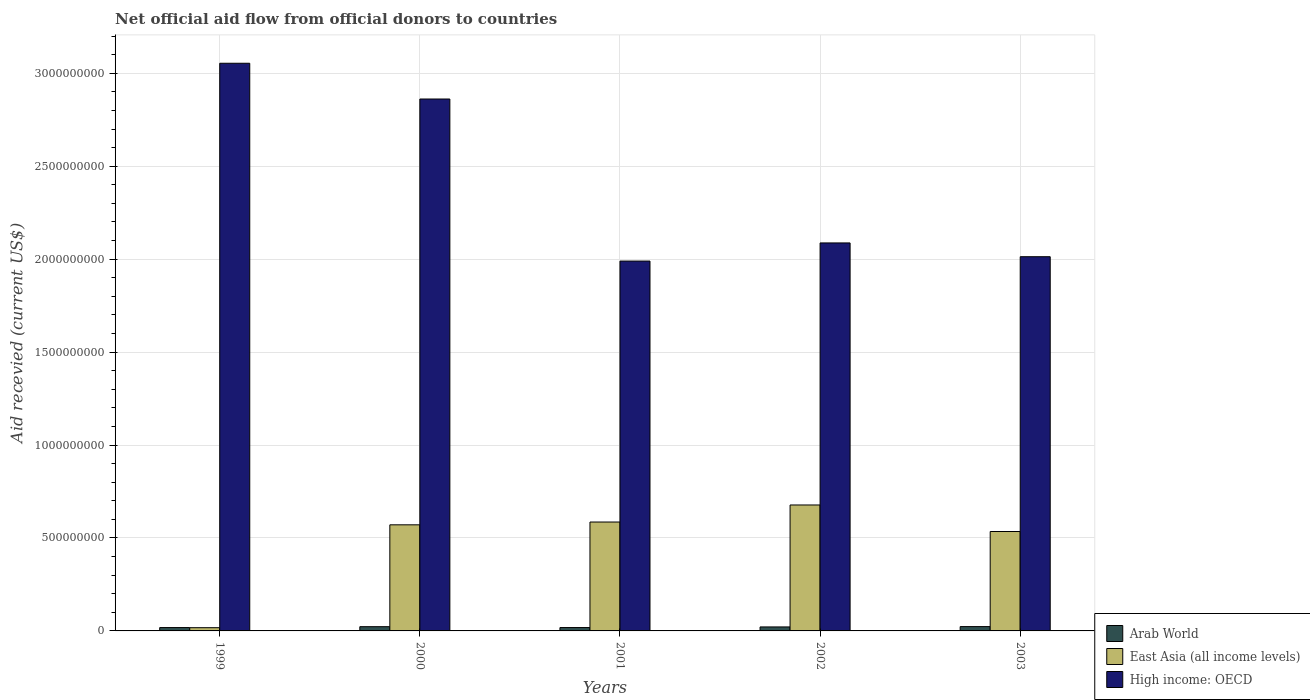Are the number of bars on each tick of the X-axis equal?
Ensure brevity in your answer.  Yes. How many bars are there on the 2nd tick from the left?
Provide a short and direct response. 3. What is the label of the 3rd group of bars from the left?
Keep it short and to the point. 2001. In how many cases, is the number of bars for a given year not equal to the number of legend labels?
Give a very brief answer. 0. What is the total aid received in Arab World in 2001?
Ensure brevity in your answer.  1.81e+07. Across all years, what is the maximum total aid received in Arab World?
Provide a succinct answer. 2.32e+07. Across all years, what is the minimum total aid received in East Asia (all income levels)?
Offer a very short reply. 1.74e+07. What is the total total aid received in Arab World in the graph?
Provide a short and direct response. 1.04e+08. What is the difference between the total aid received in Arab World in 1999 and that in 2000?
Give a very brief answer. -4.78e+06. What is the difference between the total aid received in Arab World in 2001 and the total aid received in East Asia (all income levels) in 1999?
Offer a terse response. 7.60e+05. What is the average total aid received in East Asia (all income levels) per year?
Your answer should be very brief. 4.77e+08. In the year 2002, what is the difference between the total aid received in East Asia (all income levels) and total aid received in High income: OECD?
Your response must be concise. -1.41e+09. In how many years, is the total aid received in High income: OECD greater than 700000000 US$?
Offer a very short reply. 5. What is the ratio of the total aid received in East Asia (all income levels) in 1999 to that in 2000?
Your response must be concise. 0.03. Is the difference between the total aid received in East Asia (all income levels) in 2001 and 2003 greater than the difference between the total aid received in High income: OECD in 2001 and 2003?
Ensure brevity in your answer.  Yes. What is the difference between the highest and the lowest total aid received in High income: OECD?
Offer a terse response. 1.06e+09. In how many years, is the total aid received in High income: OECD greater than the average total aid received in High income: OECD taken over all years?
Ensure brevity in your answer.  2. What does the 1st bar from the left in 1999 represents?
Make the answer very short. Arab World. What does the 3rd bar from the right in 2002 represents?
Provide a short and direct response. Arab World. Is it the case that in every year, the sum of the total aid received in East Asia (all income levels) and total aid received in High income: OECD is greater than the total aid received in Arab World?
Keep it short and to the point. Yes. How many bars are there?
Make the answer very short. 15. Are the values on the major ticks of Y-axis written in scientific E-notation?
Keep it short and to the point. No. Does the graph contain any zero values?
Ensure brevity in your answer.  No. Does the graph contain grids?
Your answer should be compact. Yes. Where does the legend appear in the graph?
Your answer should be compact. Bottom right. How many legend labels are there?
Keep it short and to the point. 3. What is the title of the graph?
Offer a very short reply. Net official aid flow from official donors to countries. Does "Suriname" appear as one of the legend labels in the graph?
Ensure brevity in your answer.  No. What is the label or title of the Y-axis?
Provide a short and direct response. Aid recevied (current US$). What is the Aid recevied (current US$) of Arab World in 1999?
Offer a very short reply. 1.80e+07. What is the Aid recevied (current US$) in East Asia (all income levels) in 1999?
Offer a terse response. 1.74e+07. What is the Aid recevied (current US$) of High income: OECD in 1999?
Your answer should be very brief. 3.05e+09. What is the Aid recevied (current US$) in Arab World in 2000?
Offer a very short reply. 2.28e+07. What is the Aid recevied (current US$) in East Asia (all income levels) in 2000?
Your response must be concise. 5.71e+08. What is the Aid recevied (current US$) of High income: OECD in 2000?
Provide a succinct answer. 2.86e+09. What is the Aid recevied (current US$) in Arab World in 2001?
Keep it short and to the point. 1.81e+07. What is the Aid recevied (current US$) in East Asia (all income levels) in 2001?
Ensure brevity in your answer.  5.86e+08. What is the Aid recevied (current US$) of High income: OECD in 2001?
Ensure brevity in your answer.  1.99e+09. What is the Aid recevied (current US$) of Arab World in 2002?
Give a very brief answer. 2.14e+07. What is the Aid recevied (current US$) in East Asia (all income levels) in 2002?
Ensure brevity in your answer.  6.78e+08. What is the Aid recevied (current US$) of High income: OECD in 2002?
Make the answer very short. 2.09e+09. What is the Aid recevied (current US$) of Arab World in 2003?
Offer a very short reply. 2.32e+07. What is the Aid recevied (current US$) in East Asia (all income levels) in 2003?
Make the answer very short. 5.35e+08. What is the Aid recevied (current US$) of High income: OECD in 2003?
Give a very brief answer. 2.01e+09. Across all years, what is the maximum Aid recevied (current US$) of Arab World?
Offer a very short reply. 2.32e+07. Across all years, what is the maximum Aid recevied (current US$) of East Asia (all income levels)?
Keep it short and to the point. 6.78e+08. Across all years, what is the maximum Aid recevied (current US$) in High income: OECD?
Provide a short and direct response. 3.05e+09. Across all years, what is the minimum Aid recevied (current US$) in Arab World?
Keep it short and to the point. 1.80e+07. Across all years, what is the minimum Aid recevied (current US$) of East Asia (all income levels)?
Ensure brevity in your answer.  1.74e+07. Across all years, what is the minimum Aid recevied (current US$) of High income: OECD?
Offer a very short reply. 1.99e+09. What is the total Aid recevied (current US$) of Arab World in the graph?
Give a very brief answer. 1.04e+08. What is the total Aid recevied (current US$) of East Asia (all income levels) in the graph?
Your answer should be very brief. 2.39e+09. What is the total Aid recevied (current US$) of High income: OECD in the graph?
Ensure brevity in your answer.  1.20e+1. What is the difference between the Aid recevied (current US$) in Arab World in 1999 and that in 2000?
Keep it short and to the point. -4.78e+06. What is the difference between the Aid recevied (current US$) in East Asia (all income levels) in 1999 and that in 2000?
Give a very brief answer. -5.53e+08. What is the difference between the Aid recevied (current US$) in High income: OECD in 1999 and that in 2000?
Give a very brief answer. 1.92e+08. What is the difference between the Aid recevied (current US$) of Arab World in 1999 and that in 2001?
Keep it short and to the point. -1.10e+05. What is the difference between the Aid recevied (current US$) in East Asia (all income levels) in 1999 and that in 2001?
Keep it short and to the point. -5.68e+08. What is the difference between the Aid recevied (current US$) in High income: OECD in 1999 and that in 2001?
Ensure brevity in your answer.  1.06e+09. What is the difference between the Aid recevied (current US$) of Arab World in 1999 and that in 2002?
Keep it short and to the point. -3.44e+06. What is the difference between the Aid recevied (current US$) of East Asia (all income levels) in 1999 and that in 2002?
Your answer should be very brief. -6.60e+08. What is the difference between the Aid recevied (current US$) in High income: OECD in 1999 and that in 2002?
Your response must be concise. 9.67e+08. What is the difference between the Aid recevied (current US$) in Arab World in 1999 and that in 2003?
Offer a terse response. -5.25e+06. What is the difference between the Aid recevied (current US$) in East Asia (all income levels) in 1999 and that in 2003?
Provide a short and direct response. -5.18e+08. What is the difference between the Aid recevied (current US$) in High income: OECD in 1999 and that in 2003?
Your answer should be very brief. 1.04e+09. What is the difference between the Aid recevied (current US$) of Arab World in 2000 and that in 2001?
Your answer should be very brief. 4.67e+06. What is the difference between the Aid recevied (current US$) in East Asia (all income levels) in 2000 and that in 2001?
Provide a succinct answer. -1.50e+07. What is the difference between the Aid recevied (current US$) in High income: OECD in 2000 and that in 2001?
Make the answer very short. 8.72e+08. What is the difference between the Aid recevied (current US$) of Arab World in 2000 and that in 2002?
Your answer should be compact. 1.34e+06. What is the difference between the Aid recevied (current US$) of East Asia (all income levels) in 2000 and that in 2002?
Give a very brief answer. -1.07e+08. What is the difference between the Aid recevied (current US$) in High income: OECD in 2000 and that in 2002?
Offer a terse response. 7.74e+08. What is the difference between the Aid recevied (current US$) of Arab World in 2000 and that in 2003?
Your answer should be compact. -4.70e+05. What is the difference between the Aid recevied (current US$) in East Asia (all income levels) in 2000 and that in 2003?
Make the answer very short. 3.59e+07. What is the difference between the Aid recevied (current US$) of High income: OECD in 2000 and that in 2003?
Ensure brevity in your answer.  8.48e+08. What is the difference between the Aid recevied (current US$) of Arab World in 2001 and that in 2002?
Give a very brief answer. -3.33e+06. What is the difference between the Aid recevied (current US$) of East Asia (all income levels) in 2001 and that in 2002?
Your answer should be very brief. -9.18e+07. What is the difference between the Aid recevied (current US$) of High income: OECD in 2001 and that in 2002?
Provide a succinct answer. -9.76e+07. What is the difference between the Aid recevied (current US$) in Arab World in 2001 and that in 2003?
Your response must be concise. -5.14e+06. What is the difference between the Aid recevied (current US$) of East Asia (all income levels) in 2001 and that in 2003?
Your answer should be compact. 5.10e+07. What is the difference between the Aid recevied (current US$) of High income: OECD in 2001 and that in 2003?
Provide a succinct answer. -2.34e+07. What is the difference between the Aid recevied (current US$) in Arab World in 2002 and that in 2003?
Your response must be concise. -1.81e+06. What is the difference between the Aid recevied (current US$) of East Asia (all income levels) in 2002 and that in 2003?
Make the answer very short. 1.43e+08. What is the difference between the Aid recevied (current US$) in High income: OECD in 2002 and that in 2003?
Your answer should be compact. 7.41e+07. What is the difference between the Aid recevied (current US$) of Arab World in 1999 and the Aid recevied (current US$) of East Asia (all income levels) in 2000?
Offer a terse response. -5.53e+08. What is the difference between the Aid recevied (current US$) of Arab World in 1999 and the Aid recevied (current US$) of High income: OECD in 2000?
Ensure brevity in your answer.  -2.84e+09. What is the difference between the Aid recevied (current US$) of East Asia (all income levels) in 1999 and the Aid recevied (current US$) of High income: OECD in 2000?
Give a very brief answer. -2.84e+09. What is the difference between the Aid recevied (current US$) of Arab World in 1999 and the Aid recevied (current US$) of East Asia (all income levels) in 2001?
Keep it short and to the point. -5.68e+08. What is the difference between the Aid recevied (current US$) of Arab World in 1999 and the Aid recevied (current US$) of High income: OECD in 2001?
Make the answer very short. -1.97e+09. What is the difference between the Aid recevied (current US$) of East Asia (all income levels) in 1999 and the Aid recevied (current US$) of High income: OECD in 2001?
Keep it short and to the point. -1.97e+09. What is the difference between the Aid recevied (current US$) in Arab World in 1999 and the Aid recevied (current US$) in East Asia (all income levels) in 2002?
Your answer should be very brief. -6.60e+08. What is the difference between the Aid recevied (current US$) of Arab World in 1999 and the Aid recevied (current US$) of High income: OECD in 2002?
Provide a short and direct response. -2.07e+09. What is the difference between the Aid recevied (current US$) in East Asia (all income levels) in 1999 and the Aid recevied (current US$) in High income: OECD in 2002?
Keep it short and to the point. -2.07e+09. What is the difference between the Aid recevied (current US$) in Arab World in 1999 and the Aid recevied (current US$) in East Asia (all income levels) in 2003?
Keep it short and to the point. -5.17e+08. What is the difference between the Aid recevied (current US$) of Arab World in 1999 and the Aid recevied (current US$) of High income: OECD in 2003?
Ensure brevity in your answer.  -2.00e+09. What is the difference between the Aid recevied (current US$) of East Asia (all income levels) in 1999 and the Aid recevied (current US$) of High income: OECD in 2003?
Your answer should be compact. -2.00e+09. What is the difference between the Aid recevied (current US$) in Arab World in 2000 and the Aid recevied (current US$) in East Asia (all income levels) in 2001?
Offer a terse response. -5.63e+08. What is the difference between the Aid recevied (current US$) in Arab World in 2000 and the Aid recevied (current US$) in High income: OECD in 2001?
Provide a succinct answer. -1.97e+09. What is the difference between the Aid recevied (current US$) in East Asia (all income levels) in 2000 and the Aid recevied (current US$) in High income: OECD in 2001?
Your answer should be very brief. -1.42e+09. What is the difference between the Aid recevied (current US$) of Arab World in 2000 and the Aid recevied (current US$) of East Asia (all income levels) in 2002?
Give a very brief answer. -6.55e+08. What is the difference between the Aid recevied (current US$) in Arab World in 2000 and the Aid recevied (current US$) in High income: OECD in 2002?
Make the answer very short. -2.06e+09. What is the difference between the Aid recevied (current US$) of East Asia (all income levels) in 2000 and the Aid recevied (current US$) of High income: OECD in 2002?
Offer a very short reply. -1.52e+09. What is the difference between the Aid recevied (current US$) in Arab World in 2000 and the Aid recevied (current US$) in East Asia (all income levels) in 2003?
Give a very brief answer. -5.12e+08. What is the difference between the Aid recevied (current US$) of Arab World in 2000 and the Aid recevied (current US$) of High income: OECD in 2003?
Offer a very short reply. -1.99e+09. What is the difference between the Aid recevied (current US$) of East Asia (all income levels) in 2000 and the Aid recevied (current US$) of High income: OECD in 2003?
Your answer should be compact. -1.44e+09. What is the difference between the Aid recevied (current US$) in Arab World in 2001 and the Aid recevied (current US$) in East Asia (all income levels) in 2002?
Make the answer very short. -6.59e+08. What is the difference between the Aid recevied (current US$) in Arab World in 2001 and the Aid recevied (current US$) in High income: OECD in 2002?
Make the answer very short. -2.07e+09. What is the difference between the Aid recevied (current US$) of East Asia (all income levels) in 2001 and the Aid recevied (current US$) of High income: OECD in 2002?
Ensure brevity in your answer.  -1.50e+09. What is the difference between the Aid recevied (current US$) of Arab World in 2001 and the Aid recevied (current US$) of East Asia (all income levels) in 2003?
Your answer should be compact. -5.17e+08. What is the difference between the Aid recevied (current US$) of Arab World in 2001 and the Aid recevied (current US$) of High income: OECD in 2003?
Your answer should be very brief. -2.00e+09. What is the difference between the Aid recevied (current US$) of East Asia (all income levels) in 2001 and the Aid recevied (current US$) of High income: OECD in 2003?
Give a very brief answer. -1.43e+09. What is the difference between the Aid recevied (current US$) of Arab World in 2002 and the Aid recevied (current US$) of East Asia (all income levels) in 2003?
Make the answer very short. -5.13e+08. What is the difference between the Aid recevied (current US$) of Arab World in 2002 and the Aid recevied (current US$) of High income: OECD in 2003?
Your response must be concise. -1.99e+09. What is the difference between the Aid recevied (current US$) in East Asia (all income levels) in 2002 and the Aid recevied (current US$) in High income: OECD in 2003?
Ensure brevity in your answer.  -1.34e+09. What is the average Aid recevied (current US$) in Arab World per year?
Provide a succinct answer. 2.07e+07. What is the average Aid recevied (current US$) in East Asia (all income levels) per year?
Give a very brief answer. 4.77e+08. What is the average Aid recevied (current US$) of High income: OECD per year?
Provide a succinct answer. 2.40e+09. In the year 1999, what is the difference between the Aid recevied (current US$) in Arab World and Aid recevied (current US$) in East Asia (all income levels)?
Your answer should be compact. 6.50e+05. In the year 1999, what is the difference between the Aid recevied (current US$) of Arab World and Aid recevied (current US$) of High income: OECD?
Offer a very short reply. -3.04e+09. In the year 1999, what is the difference between the Aid recevied (current US$) of East Asia (all income levels) and Aid recevied (current US$) of High income: OECD?
Keep it short and to the point. -3.04e+09. In the year 2000, what is the difference between the Aid recevied (current US$) of Arab World and Aid recevied (current US$) of East Asia (all income levels)?
Give a very brief answer. -5.48e+08. In the year 2000, what is the difference between the Aid recevied (current US$) in Arab World and Aid recevied (current US$) in High income: OECD?
Your answer should be very brief. -2.84e+09. In the year 2000, what is the difference between the Aid recevied (current US$) in East Asia (all income levels) and Aid recevied (current US$) in High income: OECD?
Ensure brevity in your answer.  -2.29e+09. In the year 2001, what is the difference between the Aid recevied (current US$) of Arab World and Aid recevied (current US$) of East Asia (all income levels)?
Provide a succinct answer. -5.68e+08. In the year 2001, what is the difference between the Aid recevied (current US$) of Arab World and Aid recevied (current US$) of High income: OECD?
Offer a terse response. -1.97e+09. In the year 2001, what is the difference between the Aid recevied (current US$) of East Asia (all income levels) and Aid recevied (current US$) of High income: OECD?
Offer a terse response. -1.40e+09. In the year 2002, what is the difference between the Aid recevied (current US$) of Arab World and Aid recevied (current US$) of East Asia (all income levels)?
Provide a succinct answer. -6.56e+08. In the year 2002, what is the difference between the Aid recevied (current US$) of Arab World and Aid recevied (current US$) of High income: OECD?
Give a very brief answer. -2.07e+09. In the year 2002, what is the difference between the Aid recevied (current US$) of East Asia (all income levels) and Aid recevied (current US$) of High income: OECD?
Offer a very short reply. -1.41e+09. In the year 2003, what is the difference between the Aid recevied (current US$) in Arab World and Aid recevied (current US$) in East Asia (all income levels)?
Offer a very short reply. -5.12e+08. In the year 2003, what is the difference between the Aid recevied (current US$) in Arab World and Aid recevied (current US$) in High income: OECD?
Your answer should be very brief. -1.99e+09. In the year 2003, what is the difference between the Aid recevied (current US$) of East Asia (all income levels) and Aid recevied (current US$) of High income: OECD?
Your answer should be very brief. -1.48e+09. What is the ratio of the Aid recevied (current US$) in Arab World in 1999 to that in 2000?
Keep it short and to the point. 0.79. What is the ratio of the Aid recevied (current US$) of East Asia (all income levels) in 1999 to that in 2000?
Make the answer very short. 0.03. What is the ratio of the Aid recevied (current US$) of High income: OECD in 1999 to that in 2000?
Ensure brevity in your answer.  1.07. What is the ratio of the Aid recevied (current US$) in Arab World in 1999 to that in 2001?
Your answer should be very brief. 0.99. What is the ratio of the Aid recevied (current US$) of East Asia (all income levels) in 1999 to that in 2001?
Give a very brief answer. 0.03. What is the ratio of the Aid recevied (current US$) in High income: OECD in 1999 to that in 2001?
Provide a short and direct response. 1.53. What is the ratio of the Aid recevied (current US$) of Arab World in 1999 to that in 2002?
Offer a terse response. 0.84. What is the ratio of the Aid recevied (current US$) in East Asia (all income levels) in 1999 to that in 2002?
Your answer should be compact. 0.03. What is the ratio of the Aid recevied (current US$) in High income: OECD in 1999 to that in 2002?
Keep it short and to the point. 1.46. What is the ratio of the Aid recevied (current US$) in Arab World in 1999 to that in 2003?
Provide a short and direct response. 0.77. What is the ratio of the Aid recevied (current US$) of East Asia (all income levels) in 1999 to that in 2003?
Your answer should be very brief. 0.03. What is the ratio of the Aid recevied (current US$) of High income: OECD in 1999 to that in 2003?
Provide a succinct answer. 1.52. What is the ratio of the Aid recevied (current US$) in Arab World in 2000 to that in 2001?
Provide a succinct answer. 1.26. What is the ratio of the Aid recevied (current US$) of East Asia (all income levels) in 2000 to that in 2001?
Make the answer very short. 0.97. What is the ratio of the Aid recevied (current US$) of High income: OECD in 2000 to that in 2001?
Ensure brevity in your answer.  1.44. What is the ratio of the Aid recevied (current US$) of Arab World in 2000 to that in 2002?
Make the answer very short. 1.06. What is the ratio of the Aid recevied (current US$) of East Asia (all income levels) in 2000 to that in 2002?
Your answer should be very brief. 0.84. What is the ratio of the Aid recevied (current US$) of High income: OECD in 2000 to that in 2002?
Offer a terse response. 1.37. What is the ratio of the Aid recevied (current US$) of Arab World in 2000 to that in 2003?
Ensure brevity in your answer.  0.98. What is the ratio of the Aid recevied (current US$) of East Asia (all income levels) in 2000 to that in 2003?
Offer a terse response. 1.07. What is the ratio of the Aid recevied (current US$) of High income: OECD in 2000 to that in 2003?
Provide a short and direct response. 1.42. What is the ratio of the Aid recevied (current US$) of Arab World in 2001 to that in 2002?
Offer a very short reply. 0.84. What is the ratio of the Aid recevied (current US$) of East Asia (all income levels) in 2001 to that in 2002?
Your answer should be very brief. 0.86. What is the ratio of the Aid recevied (current US$) in High income: OECD in 2001 to that in 2002?
Ensure brevity in your answer.  0.95. What is the ratio of the Aid recevied (current US$) in Arab World in 2001 to that in 2003?
Give a very brief answer. 0.78. What is the ratio of the Aid recevied (current US$) of East Asia (all income levels) in 2001 to that in 2003?
Make the answer very short. 1.1. What is the ratio of the Aid recevied (current US$) of High income: OECD in 2001 to that in 2003?
Offer a very short reply. 0.99. What is the ratio of the Aid recevied (current US$) in Arab World in 2002 to that in 2003?
Ensure brevity in your answer.  0.92. What is the ratio of the Aid recevied (current US$) of East Asia (all income levels) in 2002 to that in 2003?
Make the answer very short. 1.27. What is the ratio of the Aid recevied (current US$) in High income: OECD in 2002 to that in 2003?
Give a very brief answer. 1.04. What is the difference between the highest and the second highest Aid recevied (current US$) of Arab World?
Offer a terse response. 4.70e+05. What is the difference between the highest and the second highest Aid recevied (current US$) of East Asia (all income levels)?
Ensure brevity in your answer.  9.18e+07. What is the difference between the highest and the second highest Aid recevied (current US$) of High income: OECD?
Your answer should be compact. 1.92e+08. What is the difference between the highest and the lowest Aid recevied (current US$) in Arab World?
Provide a short and direct response. 5.25e+06. What is the difference between the highest and the lowest Aid recevied (current US$) of East Asia (all income levels)?
Offer a very short reply. 6.60e+08. What is the difference between the highest and the lowest Aid recevied (current US$) in High income: OECD?
Provide a short and direct response. 1.06e+09. 